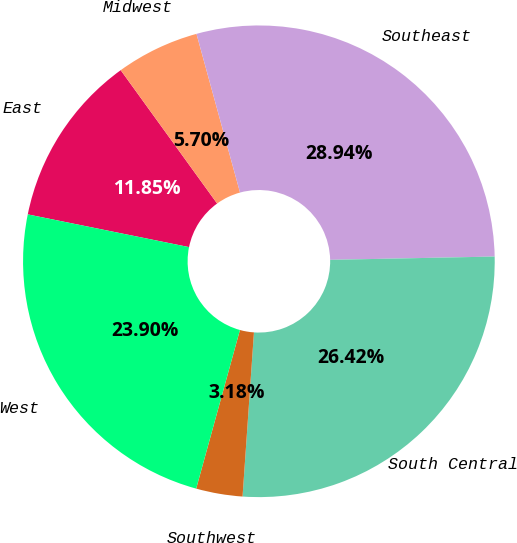Convert chart to OTSL. <chart><loc_0><loc_0><loc_500><loc_500><pie_chart><fcel>East<fcel>Midwest<fcel>Southeast<fcel>South Central<fcel>Southwest<fcel>West<nl><fcel>11.85%<fcel>5.7%<fcel>28.94%<fcel>26.42%<fcel>3.18%<fcel>23.9%<nl></chart> 